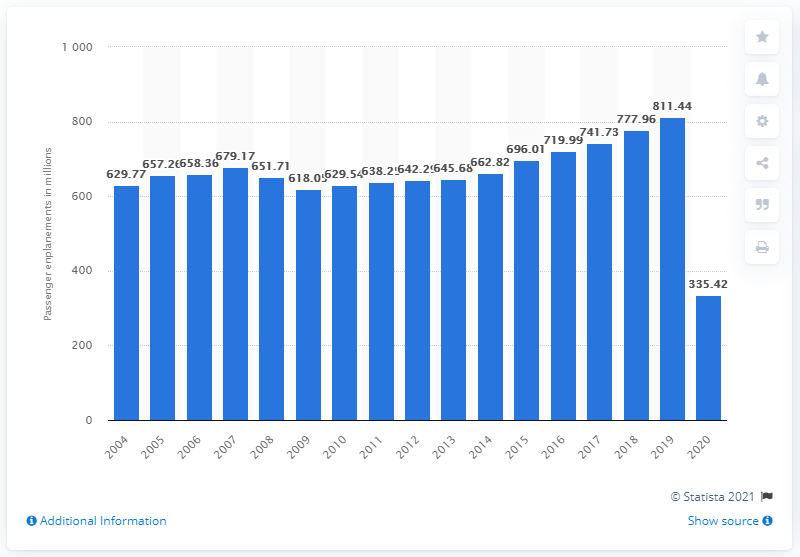Point out several critical features in this image. In 2020, U.S. airlines carried a total of 335,420 passengers on domestic flights. 